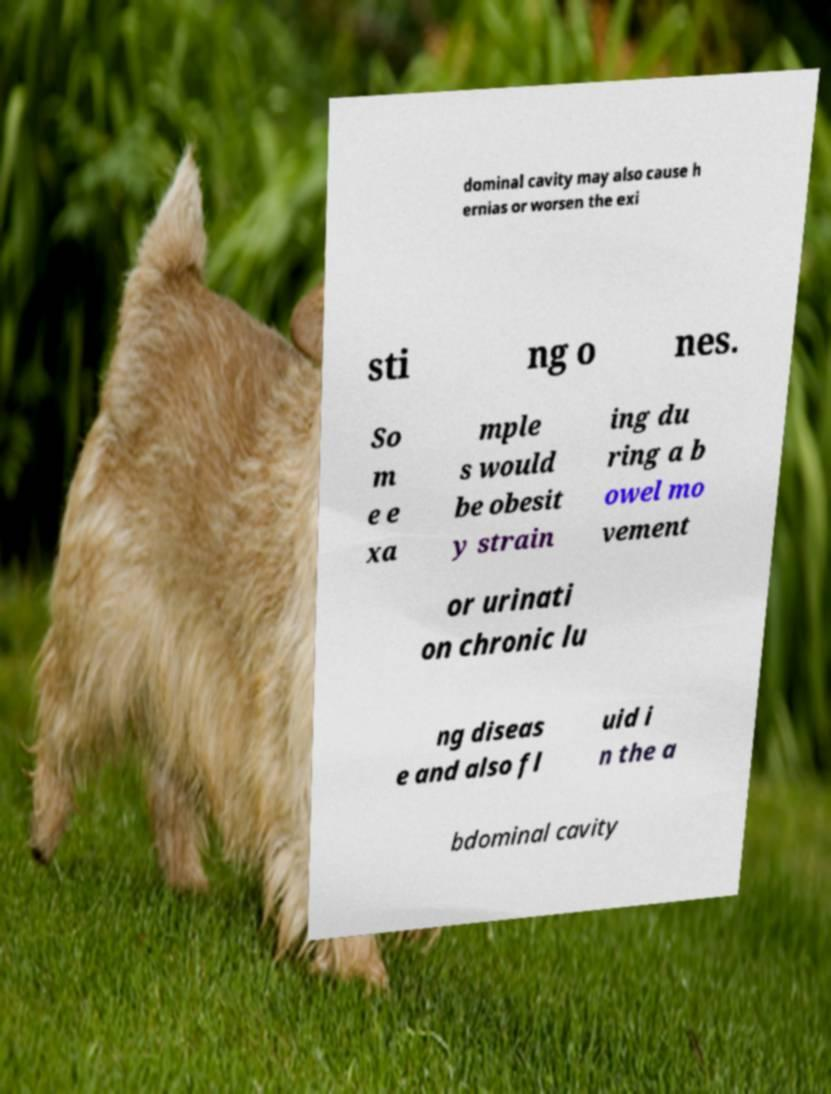Can you read and provide the text displayed in the image?This photo seems to have some interesting text. Can you extract and type it out for me? dominal cavity may also cause h ernias or worsen the exi sti ng o nes. So m e e xa mple s would be obesit y strain ing du ring a b owel mo vement or urinati on chronic lu ng diseas e and also fl uid i n the a bdominal cavity 